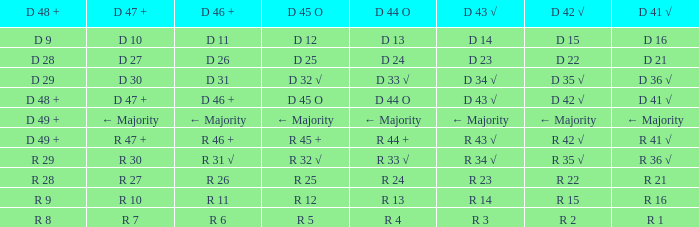What is the value of D 46 +, when the value of D 42 √ is r 2? R 6. 